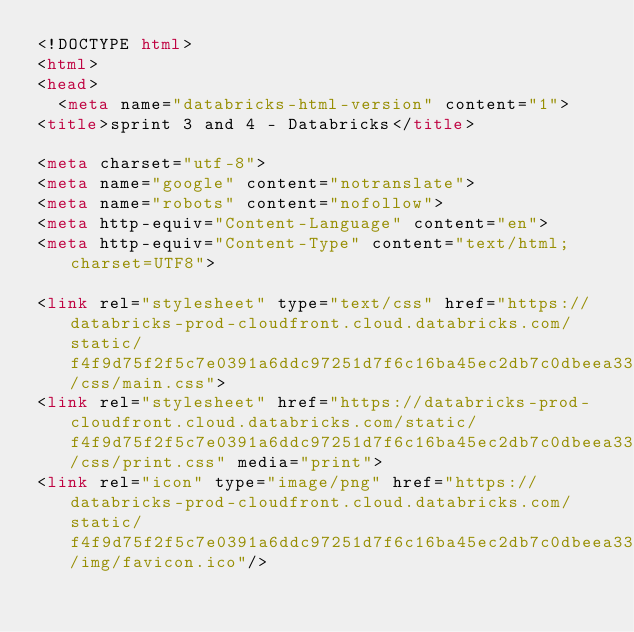Convert code to text. <code><loc_0><loc_0><loc_500><loc_500><_HTML_><!DOCTYPE html>
<html>
<head>
  <meta name="databricks-html-version" content="1">
<title>sprint 3 and 4 - Databricks</title>

<meta charset="utf-8">
<meta name="google" content="notranslate">
<meta name="robots" content="nofollow">
<meta http-equiv="Content-Language" content="en">
<meta http-equiv="Content-Type" content="text/html; charset=UTF8">

<link rel="stylesheet" type="text/css" href="https://databricks-prod-cloudfront.cloud.databricks.com/static/f4f9d75f2f5c7e0391a6ddc97251d7f6c16ba45ec2db7c0dbeea3338f3fcad7f/css/main.css">
<link rel="stylesheet" href="https://databricks-prod-cloudfront.cloud.databricks.com/static/f4f9d75f2f5c7e0391a6ddc97251d7f6c16ba45ec2db7c0dbeea3338f3fcad7f/css/print.css" media="print">
<link rel="icon" type="image/png" href="https://databricks-prod-cloudfront.cloud.databricks.com/static/f4f9d75f2f5c7e0391a6ddc97251d7f6c16ba45ec2db7c0dbeea3338f3fcad7f/img/favicon.ico"/></code> 